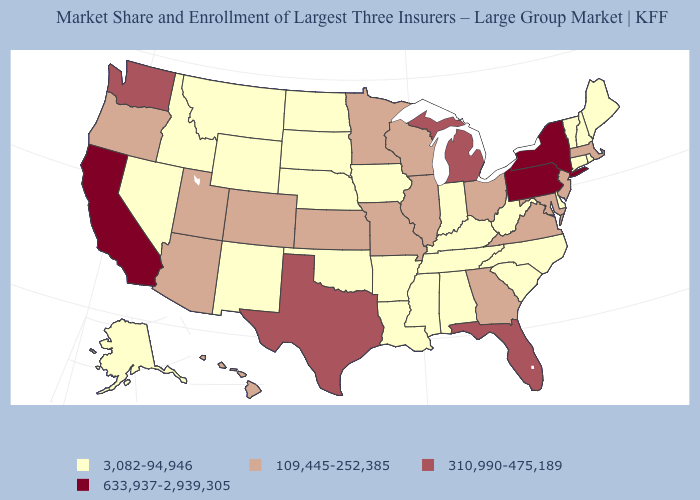What is the highest value in states that border Connecticut?
Short answer required. 633,937-2,939,305. Among the states that border Massachusetts , does New Hampshire have the lowest value?
Quick response, please. Yes. What is the value of Delaware?
Keep it brief. 3,082-94,946. What is the value of Colorado?
Keep it brief. 109,445-252,385. Name the states that have a value in the range 3,082-94,946?
Answer briefly. Alabama, Alaska, Arkansas, Connecticut, Delaware, Idaho, Indiana, Iowa, Kentucky, Louisiana, Maine, Mississippi, Montana, Nebraska, Nevada, New Hampshire, New Mexico, North Carolina, North Dakota, Oklahoma, Rhode Island, South Carolina, South Dakota, Tennessee, Vermont, West Virginia, Wyoming. What is the value of Connecticut?
Write a very short answer. 3,082-94,946. What is the value of South Carolina?
Answer briefly. 3,082-94,946. Does New Jersey have the highest value in the USA?
Write a very short answer. No. What is the value of North Carolina?
Keep it brief. 3,082-94,946. What is the value of Delaware?
Write a very short answer. 3,082-94,946. What is the highest value in the USA?
Be succinct. 633,937-2,939,305. Does Michigan have the highest value in the MidWest?
Give a very brief answer. Yes. What is the value of New York?
Write a very short answer. 633,937-2,939,305. What is the lowest value in states that border North Dakota?
Answer briefly. 3,082-94,946. What is the lowest value in the Northeast?
Concise answer only. 3,082-94,946. 